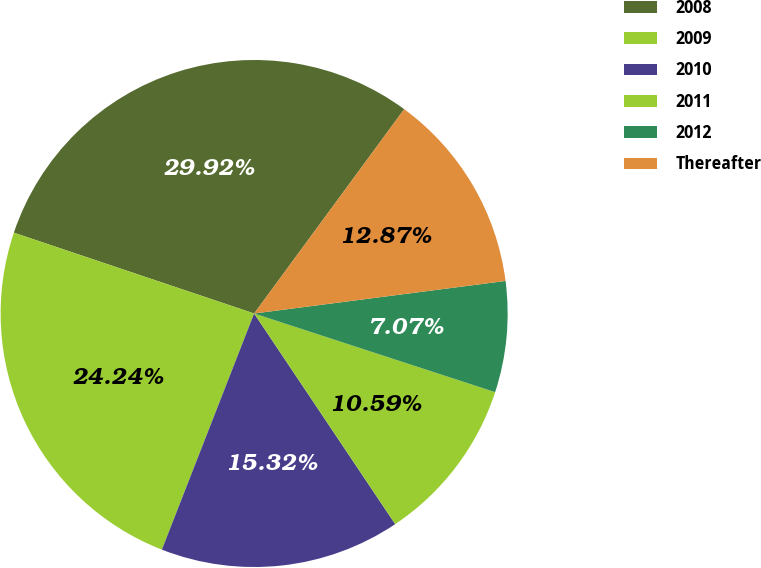<chart> <loc_0><loc_0><loc_500><loc_500><pie_chart><fcel>2008<fcel>2009<fcel>2010<fcel>2011<fcel>2012<fcel>Thereafter<nl><fcel>29.92%<fcel>24.24%<fcel>15.32%<fcel>10.59%<fcel>7.07%<fcel>12.87%<nl></chart> 